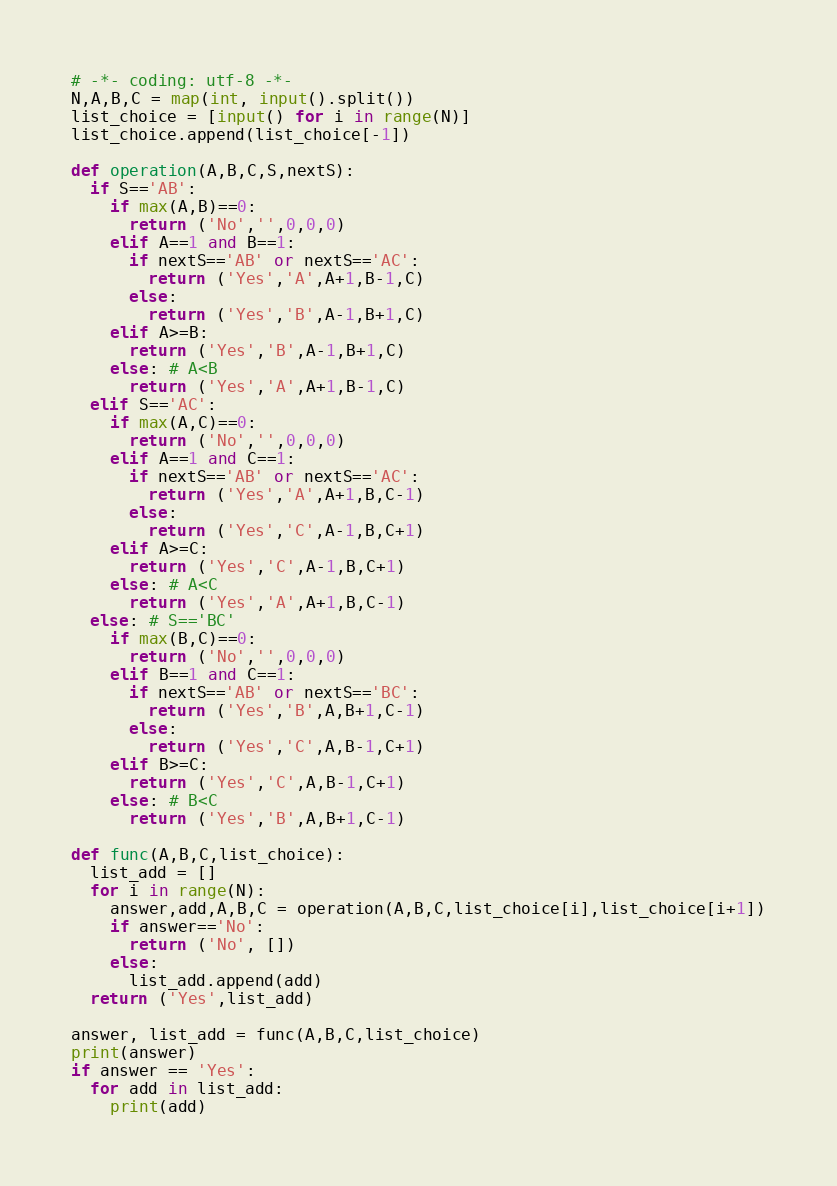<code> <loc_0><loc_0><loc_500><loc_500><_Python_># -*- coding: utf-8 -*-
N,A,B,C = map(int, input().split())
list_choice = [input() for i in range(N)]
list_choice.append(list_choice[-1])

def operation(A,B,C,S,nextS):
  if S=='AB':
    if max(A,B)==0:
      return ('No','',0,0,0)
    elif A==1 and B==1:
      if nextS=='AB' or nextS=='AC':
        return ('Yes','A',A+1,B-1,C)
      else:
        return ('Yes','B',A-1,B+1,C)  
    elif A>=B:
      return ('Yes','B',A-1,B+1,C)
    else: # A<B
      return ('Yes','A',A+1,B-1,C)
  elif S=='AC':
    if max(A,C)==0:
      return ('No','',0,0,0)
    elif A==1 and C==1:
      if nextS=='AB' or nextS=='AC':
        return ('Yes','A',A+1,B,C-1)
      else:
        return ('Yes','C',A-1,B,C+1)  
    elif A>=C:
      return ('Yes','C',A-1,B,C+1)
    else: # A<C
      return ('Yes','A',A+1,B,C-1)
  else: # S=='BC'
    if max(B,C)==0:
      return ('No','',0,0,0)
    elif B==1 and C==1:
      if nextS=='AB' or nextS=='BC':
        return ('Yes','B',A,B+1,C-1)
      else:
        return ('Yes','C',A,B-1,C+1)  
    elif B>=C:
      return ('Yes','C',A,B-1,C+1)
    else: # B<C
      return ('Yes','B',A,B+1,C-1)
  
def func(A,B,C,list_choice):
  list_add = []
  for i in range(N):
    answer,add,A,B,C = operation(A,B,C,list_choice[i],list_choice[i+1])
    if answer=='No':
      return ('No', [])
    else:
      list_add.append(add)
  return ('Yes',list_add)
  
answer, list_add = func(A,B,C,list_choice)
print(answer)
if answer == 'Yes':
  for add in list_add:
    print(add)</code> 